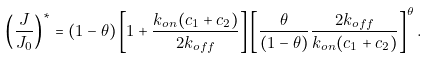Convert formula to latex. <formula><loc_0><loc_0><loc_500><loc_500>\left ( \frac { J } { J _ { 0 } } \right ) ^ { * } = ( 1 - \theta ) \left [ 1 + \frac { k _ { o n } ( c _ { 1 } + c _ { 2 } ) } { 2 k _ { o f f } } \right ] \left [ \frac { \theta } { ( 1 - \theta ) } \frac { 2 k _ { o f f } } { k _ { o n } ( c _ { 1 } + c _ { 2 } ) } \right ] ^ { \theta } .</formula> 